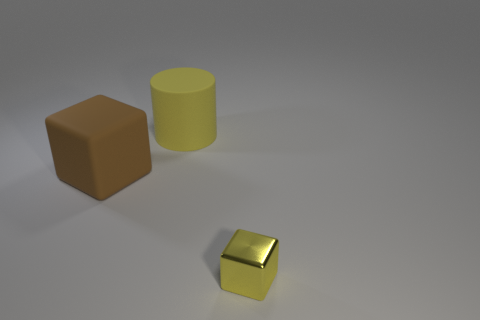Is there any other thing that is the same shape as the yellow matte thing?
Your response must be concise. No. What number of yellow rubber cylinders are behind the object that is on the right side of the yellow matte cylinder?
Your answer should be compact. 1. Does the tiny shiny object to the right of the big cube have the same color as the large matte cylinder?
Your answer should be compact. Yes. There is a metallic block to the right of the large thing that is in front of the cylinder; are there any big yellow rubber things that are to the right of it?
Offer a terse response. No. What shape is the object that is to the right of the brown cube and to the left of the tiny cube?
Your response must be concise. Cylinder. Is there a tiny rubber ball of the same color as the large rubber block?
Your answer should be very brief. No. The big matte object that is on the right side of the block behind the small yellow thing is what color?
Your answer should be compact. Yellow. There is a block that is on the right side of the cube on the left side of the cube in front of the large block; how big is it?
Your response must be concise. Small. Do the large cylinder and the yellow object that is right of the yellow rubber object have the same material?
Offer a very short reply. No. The cylinder that is the same material as the brown block is what size?
Give a very brief answer. Large. 